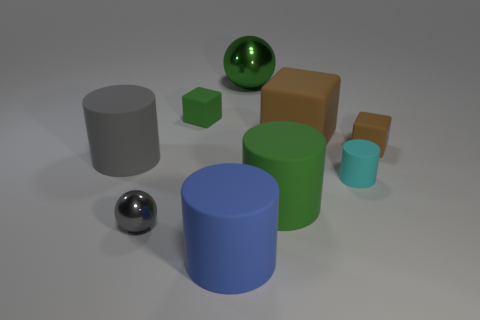Subtract 1 cylinders. How many cylinders are left? 3 Subtract all cylinders. How many objects are left? 5 Subtract all tiny gray things. Subtract all small shiny balls. How many objects are left? 7 Add 1 gray objects. How many gray objects are left? 3 Add 2 cyan rubber cylinders. How many cyan rubber cylinders exist? 3 Subtract 2 brown blocks. How many objects are left? 7 